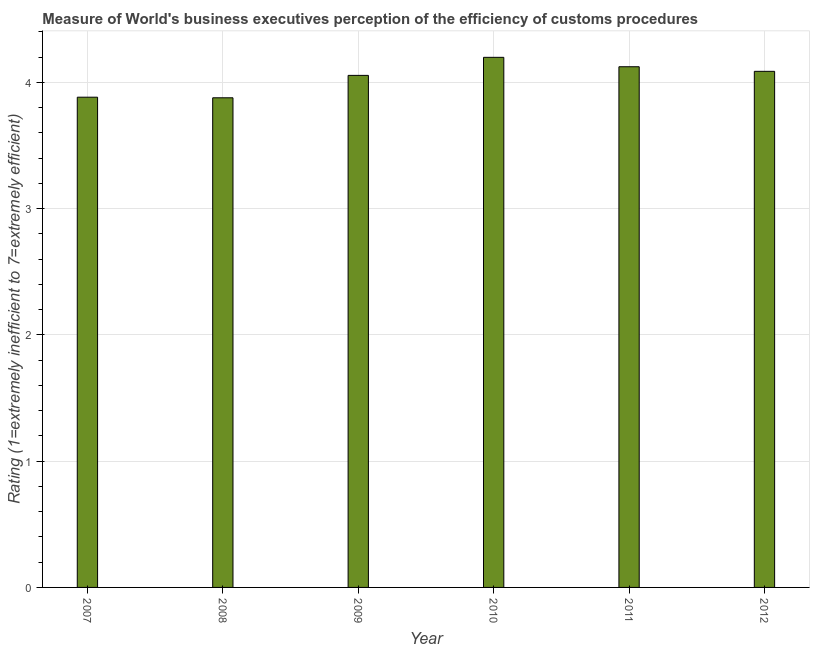Does the graph contain grids?
Ensure brevity in your answer.  Yes. What is the title of the graph?
Offer a terse response. Measure of World's business executives perception of the efficiency of customs procedures. What is the label or title of the X-axis?
Your answer should be compact. Year. What is the label or title of the Y-axis?
Provide a succinct answer. Rating (1=extremely inefficient to 7=extremely efficient). What is the rating measuring burden of customs procedure in 2009?
Keep it short and to the point. 4.06. Across all years, what is the maximum rating measuring burden of customs procedure?
Give a very brief answer. 4.2. Across all years, what is the minimum rating measuring burden of customs procedure?
Offer a very short reply. 3.88. In which year was the rating measuring burden of customs procedure maximum?
Your answer should be very brief. 2010. What is the sum of the rating measuring burden of customs procedure?
Your answer should be compact. 24.23. What is the difference between the rating measuring burden of customs procedure in 2011 and 2012?
Keep it short and to the point. 0.04. What is the average rating measuring burden of customs procedure per year?
Give a very brief answer. 4.04. What is the median rating measuring burden of customs procedure?
Keep it short and to the point. 4.07. In how many years, is the rating measuring burden of customs procedure greater than 1 ?
Give a very brief answer. 6. Do a majority of the years between 2009 and 2012 (inclusive) have rating measuring burden of customs procedure greater than 1.4 ?
Offer a very short reply. Yes. Is the difference between the rating measuring burden of customs procedure in 2009 and 2012 greater than the difference between any two years?
Your answer should be compact. No. What is the difference between the highest and the second highest rating measuring burden of customs procedure?
Ensure brevity in your answer.  0.07. Is the sum of the rating measuring burden of customs procedure in 2009 and 2010 greater than the maximum rating measuring burden of customs procedure across all years?
Your answer should be compact. Yes. What is the difference between the highest and the lowest rating measuring burden of customs procedure?
Make the answer very short. 0.32. In how many years, is the rating measuring burden of customs procedure greater than the average rating measuring burden of customs procedure taken over all years?
Provide a short and direct response. 4. How many years are there in the graph?
Provide a short and direct response. 6. What is the Rating (1=extremely inefficient to 7=extremely efficient) of 2007?
Offer a terse response. 3.88. What is the Rating (1=extremely inefficient to 7=extremely efficient) in 2008?
Ensure brevity in your answer.  3.88. What is the Rating (1=extremely inefficient to 7=extremely efficient) in 2009?
Ensure brevity in your answer.  4.06. What is the Rating (1=extremely inefficient to 7=extremely efficient) in 2010?
Offer a terse response. 4.2. What is the Rating (1=extremely inefficient to 7=extremely efficient) in 2011?
Your response must be concise. 4.12. What is the Rating (1=extremely inefficient to 7=extremely efficient) of 2012?
Provide a short and direct response. 4.09. What is the difference between the Rating (1=extremely inefficient to 7=extremely efficient) in 2007 and 2008?
Your answer should be compact. 0. What is the difference between the Rating (1=extremely inefficient to 7=extremely efficient) in 2007 and 2009?
Keep it short and to the point. -0.17. What is the difference between the Rating (1=extremely inefficient to 7=extremely efficient) in 2007 and 2010?
Keep it short and to the point. -0.32. What is the difference between the Rating (1=extremely inefficient to 7=extremely efficient) in 2007 and 2011?
Your response must be concise. -0.24. What is the difference between the Rating (1=extremely inefficient to 7=extremely efficient) in 2007 and 2012?
Your answer should be compact. -0.2. What is the difference between the Rating (1=extremely inefficient to 7=extremely efficient) in 2008 and 2009?
Offer a terse response. -0.18. What is the difference between the Rating (1=extremely inefficient to 7=extremely efficient) in 2008 and 2010?
Your answer should be very brief. -0.32. What is the difference between the Rating (1=extremely inefficient to 7=extremely efficient) in 2008 and 2011?
Your response must be concise. -0.25. What is the difference between the Rating (1=extremely inefficient to 7=extremely efficient) in 2008 and 2012?
Provide a succinct answer. -0.21. What is the difference between the Rating (1=extremely inefficient to 7=extremely efficient) in 2009 and 2010?
Provide a short and direct response. -0.14. What is the difference between the Rating (1=extremely inefficient to 7=extremely efficient) in 2009 and 2011?
Provide a succinct answer. -0.07. What is the difference between the Rating (1=extremely inefficient to 7=extremely efficient) in 2009 and 2012?
Your response must be concise. -0.03. What is the difference between the Rating (1=extremely inefficient to 7=extremely efficient) in 2010 and 2011?
Keep it short and to the point. 0.07. What is the difference between the Rating (1=extremely inefficient to 7=extremely efficient) in 2010 and 2012?
Give a very brief answer. 0.11. What is the difference between the Rating (1=extremely inefficient to 7=extremely efficient) in 2011 and 2012?
Keep it short and to the point. 0.04. What is the ratio of the Rating (1=extremely inefficient to 7=extremely efficient) in 2007 to that in 2009?
Your answer should be compact. 0.96. What is the ratio of the Rating (1=extremely inefficient to 7=extremely efficient) in 2007 to that in 2010?
Keep it short and to the point. 0.93. What is the ratio of the Rating (1=extremely inefficient to 7=extremely efficient) in 2007 to that in 2011?
Provide a succinct answer. 0.94. What is the ratio of the Rating (1=extremely inefficient to 7=extremely efficient) in 2007 to that in 2012?
Offer a very short reply. 0.95. What is the ratio of the Rating (1=extremely inefficient to 7=extremely efficient) in 2008 to that in 2009?
Your response must be concise. 0.96. What is the ratio of the Rating (1=extremely inefficient to 7=extremely efficient) in 2008 to that in 2010?
Ensure brevity in your answer.  0.92. What is the ratio of the Rating (1=extremely inefficient to 7=extremely efficient) in 2008 to that in 2012?
Give a very brief answer. 0.95. What is the ratio of the Rating (1=extremely inefficient to 7=extremely efficient) in 2009 to that in 2010?
Ensure brevity in your answer.  0.97. What is the ratio of the Rating (1=extremely inefficient to 7=extremely efficient) in 2009 to that in 2011?
Keep it short and to the point. 0.98. What is the ratio of the Rating (1=extremely inefficient to 7=extremely efficient) in 2010 to that in 2011?
Provide a short and direct response. 1.02. What is the ratio of the Rating (1=extremely inefficient to 7=extremely efficient) in 2010 to that in 2012?
Keep it short and to the point. 1.03. 